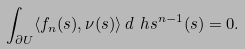Convert formula to latex. <formula><loc_0><loc_0><loc_500><loc_500>\int _ { \partial U } \langle f _ { n } ( s ) , \nu ( s ) \rangle \, d \ h s ^ { n - 1 } ( s ) = 0 .</formula> 